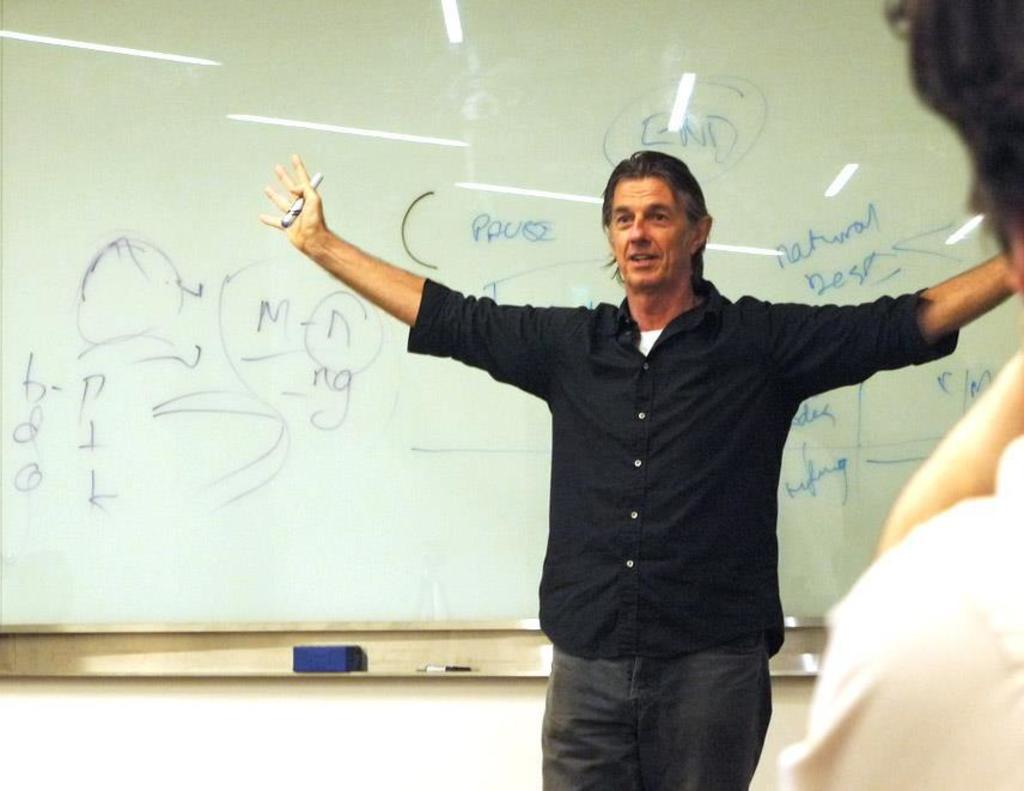Provide a one-sentence caption for the provided image. A man stands in front of a whiteboard with the word END right over his head. 